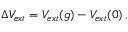Convert formula to latex. <formula><loc_0><loc_0><loc_500><loc_500>\begin{array} { r } { \Delta V _ { e x t } = V _ { e x t } ( g ) - V _ { e x t } ( 0 ) \, , } \end{array}</formula> 